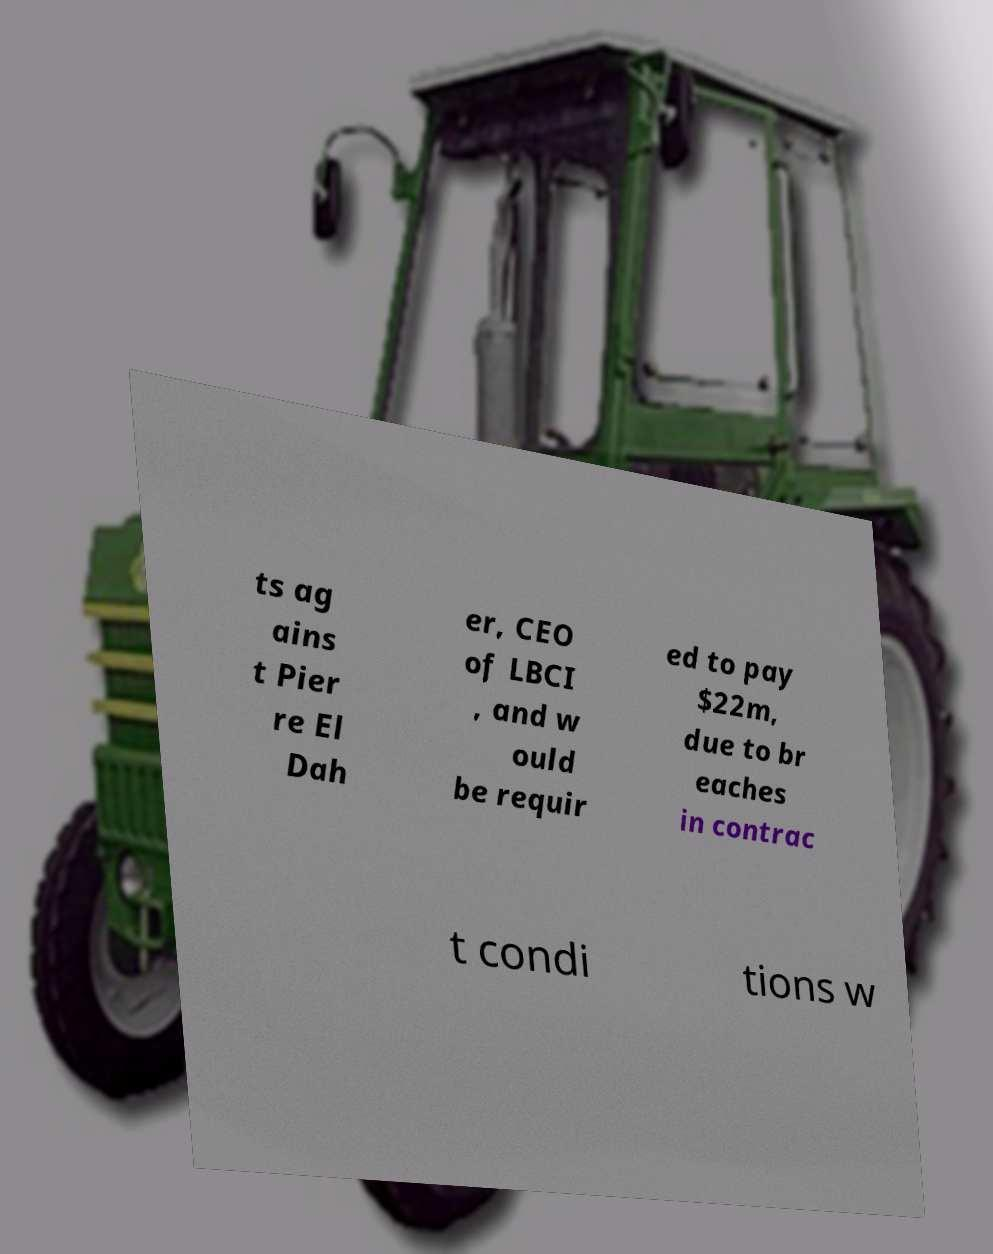There's text embedded in this image that I need extracted. Can you transcribe it verbatim? ts ag ains t Pier re El Dah er, CEO of LBCI , and w ould be requir ed to pay $22m, due to br eaches in contrac t condi tions w 